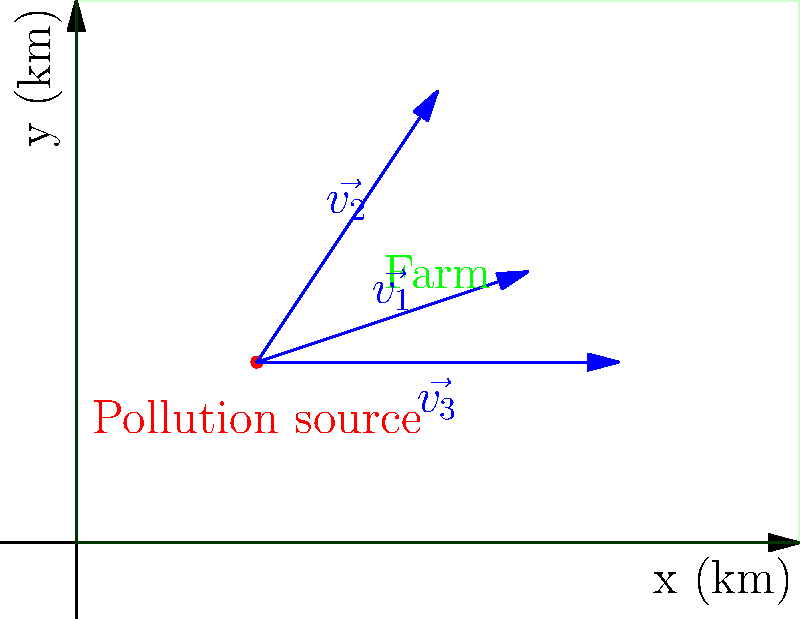An industrial pollution source is located at (1,1) km on your farmland. Three vectors represent the spread of pollution: $\vec{v_1} = \langle 1.5, 0.5 \rangle$, $\vec{v_2} = \langle 1, 1.5 \rangle$, and $\vec{v_3} = \langle 2, 0 \rangle$ (in km). Calculate the total area potentially affected by pollution after one time unit, assuming the pollution spreads in a triangular region defined by these vectors. To solve this problem, we'll follow these steps:

1) The area potentially affected by pollution forms a triangle. We can calculate its area using the cross product of two vectors.

2) We'll use $\vec{v_1}$ and $\vec{v_2}$ to calculate the area. The formula for the area of a parallelogram formed by two vectors $\vec{a}$ and $\vec{b}$ is:

   Area = $|\vec{a} \times \vec{b}|$

3) For 2D vectors $\vec{a} = \langle a_1, a_2 \rangle$ and $\vec{b} = \langle b_1, b_2 \rangle$, the magnitude of their cross product is:

   $|\vec{a} \times \vec{b}| = |a_1b_2 - a_2b_1|$

4) Substituting our vectors:
   $\vec{v_1} = \langle 1.5, 0.5 \rangle$
   $\vec{v_2} = \langle 1, 1.5 \rangle$

5) Calculate the cross product:
   $|\vec{v_1} \times \vec{v_2}| = |(1.5)(1.5) - (0.5)(1)|$
                                 $= |2.25 - 0.5|$
                                 $= 1.75$

6) This gives us the area of the parallelogram. Since we want the area of the triangle, we divide by 2:

   Triangle Area = $\frac{1.75}{2} = 0.875$ sq km

Therefore, the total area potentially affected by pollution after one time unit is 0.875 sq km.
Answer: 0.875 sq km 